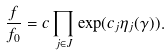Convert formula to latex. <formula><loc_0><loc_0><loc_500><loc_500>\frac { f } { f _ { 0 } } = c \prod _ { j \in J } \exp ( c _ { j } \eta _ { j } ( \gamma ) ) .</formula> 